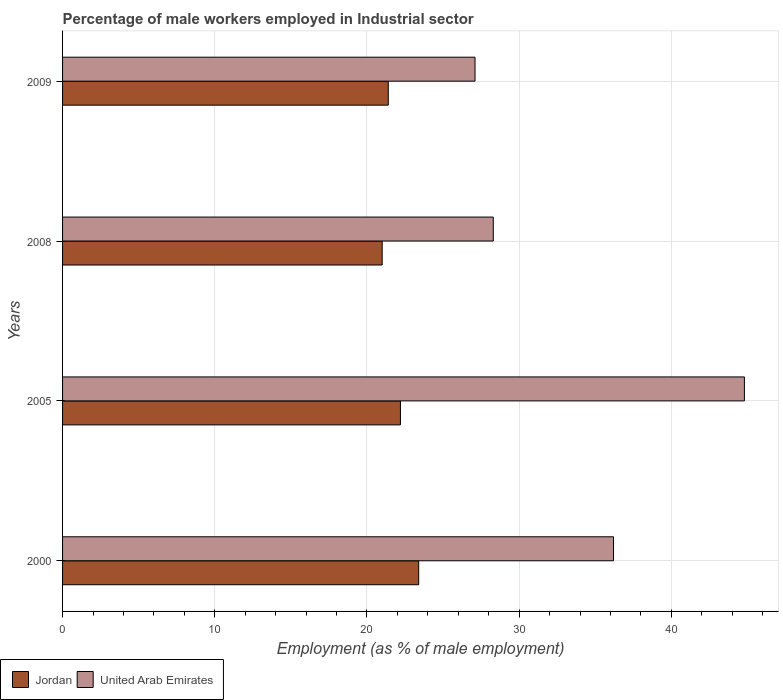How many different coloured bars are there?
Ensure brevity in your answer.  2. Are the number of bars on each tick of the Y-axis equal?
Make the answer very short. Yes. How many bars are there on the 1st tick from the top?
Provide a short and direct response. 2. What is the label of the 1st group of bars from the top?
Make the answer very short. 2009. In how many cases, is the number of bars for a given year not equal to the number of legend labels?
Give a very brief answer. 0. What is the percentage of male workers employed in Industrial sector in Jordan in 2008?
Ensure brevity in your answer.  21. Across all years, what is the maximum percentage of male workers employed in Industrial sector in United Arab Emirates?
Make the answer very short. 44.8. Across all years, what is the minimum percentage of male workers employed in Industrial sector in United Arab Emirates?
Give a very brief answer. 27.1. In which year was the percentage of male workers employed in Industrial sector in United Arab Emirates minimum?
Offer a very short reply. 2009. What is the total percentage of male workers employed in Industrial sector in United Arab Emirates in the graph?
Keep it short and to the point. 136.4. What is the difference between the percentage of male workers employed in Industrial sector in Jordan in 2000 and that in 2008?
Make the answer very short. 2.4. What is the difference between the percentage of male workers employed in Industrial sector in Jordan in 2005 and the percentage of male workers employed in Industrial sector in United Arab Emirates in 2008?
Make the answer very short. -6.1. What is the average percentage of male workers employed in Industrial sector in United Arab Emirates per year?
Your response must be concise. 34.1. In the year 2009, what is the difference between the percentage of male workers employed in Industrial sector in Jordan and percentage of male workers employed in Industrial sector in United Arab Emirates?
Your answer should be very brief. -5.7. What is the ratio of the percentage of male workers employed in Industrial sector in Jordan in 2005 to that in 2008?
Give a very brief answer. 1.06. Is the percentage of male workers employed in Industrial sector in Jordan in 2005 less than that in 2008?
Make the answer very short. No. What is the difference between the highest and the second highest percentage of male workers employed in Industrial sector in United Arab Emirates?
Give a very brief answer. 8.6. What is the difference between the highest and the lowest percentage of male workers employed in Industrial sector in United Arab Emirates?
Offer a terse response. 17.7. What does the 2nd bar from the top in 2000 represents?
Offer a terse response. Jordan. What does the 1st bar from the bottom in 2009 represents?
Offer a terse response. Jordan. How many bars are there?
Your answer should be compact. 8. Are all the bars in the graph horizontal?
Offer a very short reply. Yes. Does the graph contain grids?
Keep it short and to the point. Yes. Where does the legend appear in the graph?
Ensure brevity in your answer.  Bottom left. What is the title of the graph?
Keep it short and to the point. Percentage of male workers employed in Industrial sector. What is the label or title of the X-axis?
Make the answer very short. Employment (as % of male employment). What is the label or title of the Y-axis?
Your answer should be very brief. Years. What is the Employment (as % of male employment) of Jordan in 2000?
Provide a short and direct response. 23.4. What is the Employment (as % of male employment) of United Arab Emirates in 2000?
Give a very brief answer. 36.2. What is the Employment (as % of male employment) in Jordan in 2005?
Keep it short and to the point. 22.2. What is the Employment (as % of male employment) in United Arab Emirates in 2005?
Offer a very short reply. 44.8. What is the Employment (as % of male employment) in Jordan in 2008?
Provide a succinct answer. 21. What is the Employment (as % of male employment) of United Arab Emirates in 2008?
Offer a very short reply. 28.3. What is the Employment (as % of male employment) in Jordan in 2009?
Provide a short and direct response. 21.4. What is the Employment (as % of male employment) in United Arab Emirates in 2009?
Provide a short and direct response. 27.1. Across all years, what is the maximum Employment (as % of male employment) of Jordan?
Your answer should be very brief. 23.4. Across all years, what is the maximum Employment (as % of male employment) in United Arab Emirates?
Provide a succinct answer. 44.8. Across all years, what is the minimum Employment (as % of male employment) of Jordan?
Ensure brevity in your answer.  21. Across all years, what is the minimum Employment (as % of male employment) of United Arab Emirates?
Your answer should be compact. 27.1. What is the total Employment (as % of male employment) in United Arab Emirates in the graph?
Your answer should be compact. 136.4. What is the difference between the Employment (as % of male employment) in United Arab Emirates in 2000 and that in 2005?
Keep it short and to the point. -8.6. What is the difference between the Employment (as % of male employment) of Jordan in 2000 and that in 2008?
Offer a very short reply. 2.4. What is the difference between the Employment (as % of male employment) of Jordan in 2000 and that in 2009?
Give a very brief answer. 2. What is the difference between the Employment (as % of male employment) in United Arab Emirates in 2005 and that in 2008?
Keep it short and to the point. 16.5. What is the difference between the Employment (as % of male employment) in Jordan in 2005 and that in 2009?
Make the answer very short. 0.8. What is the difference between the Employment (as % of male employment) of United Arab Emirates in 2008 and that in 2009?
Your answer should be compact. 1.2. What is the difference between the Employment (as % of male employment) in Jordan in 2000 and the Employment (as % of male employment) in United Arab Emirates in 2005?
Ensure brevity in your answer.  -21.4. What is the difference between the Employment (as % of male employment) of Jordan in 2000 and the Employment (as % of male employment) of United Arab Emirates in 2008?
Offer a terse response. -4.9. What is the difference between the Employment (as % of male employment) in Jordan in 2005 and the Employment (as % of male employment) in United Arab Emirates in 2008?
Offer a terse response. -6.1. What is the average Employment (as % of male employment) of United Arab Emirates per year?
Make the answer very short. 34.1. In the year 2005, what is the difference between the Employment (as % of male employment) in Jordan and Employment (as % of male employment) in United Arab Emirates?
Your answer should be very brief. -22.6. In the year 2008, what is the difference between the Employment (as % of male employment) in Jordan and Employment (as % of male employment) in United Arab Emirates?
Give a very brief answer. -7.3. In the year 2009, what is the difference between the Employment (as % of male employment) in Jordan and Employment (as % of male employment) in United Arab Emirates?
Offer a terse response. -5.7. What is the ratio of the Employment (as % of male employment) of Jordan in 2000 to that in 2005?
Your answer should be compact. 1.05. What is the ratio of the Employment (as % of male employment) of United Arab Emirates in 2000 to that in 2005?
Keep it short and to the point. 0.81. What is the ratio of the Employment (as % of male employment) in Jordan in 2000 to that in 2008?
Your response must be concise. 1.11. What is the ratio of the Employment (as % of male employment) in United Arab Emirates in 2000 to that in 2008?
Your response must be concise. 1.28. What is the ratio of the Employment (as % of male employment) of Jordan in 2000 to that in 2009?
Your response must be concise. 1.09. What is the ratio of the Employment (as % of male employment) in United Arab Emirates in 2000 to that in 2009?
Offer a very short reply. 1.34. What is the ratio of the Employment (as % of male employment) of Jordan in 2005 to that in 2008?
Offer a terse response. 1.06. What is the ratio of the Employment (as % of male employment) of United Arab Emirates in 2005 to that in 2008?
Your answer should be very brief. 1.58. What is the ratio of the Employment (as % of male employment) of Jordan in 2005 to that in 2009?
Provide a short and direct response. 1.04. What is the ratio of the Employment (as % of male employment) of United Arab Emirates in 2005 to that in 2009?
Provide a short and direct response. 1.65. What is the ratio of the Employment (as % of male employment) in Jordan in 2008 to that in 2009?
Offer a terse response. 0.98. What is the ratio of the Employment (as % of male employment) of United Arab Emirates in 2008 to that in 2009?
Give a very brief answer. 1.04. What is the difference between the highest and the second highest Employment (as % of male employment) of United Arab Emirates?
Provide a succinct answer. 8.6. 